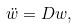Convert formula to latex. <formula><loc_0><loc_0><loc_500><loc_500>\ddot { w } = D w ,</formula> 